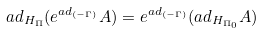<formula> <loc_0><loc_0><loc_500><loc_500>a d _ { H _ { \Pi } } ( e ^ { a d _ { ( - \Gamma ) } } A ) = e ^ { a d _ { ( - \Gamma ) } } ( a d _ { H _ { \Pi _ { 0 } } } A )</formula> 